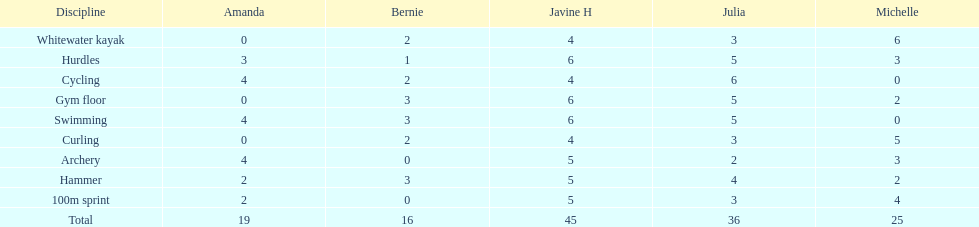Can you mention a girl who obtained equal points in cycling and archery competitions? Amanda. 